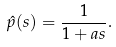Convert formula to latex. <formula><loc_0><loc_0><loc_500><loc_500>\hat { p } ( s ) = \frac { 1 } { 1 + a s } .</formula> 